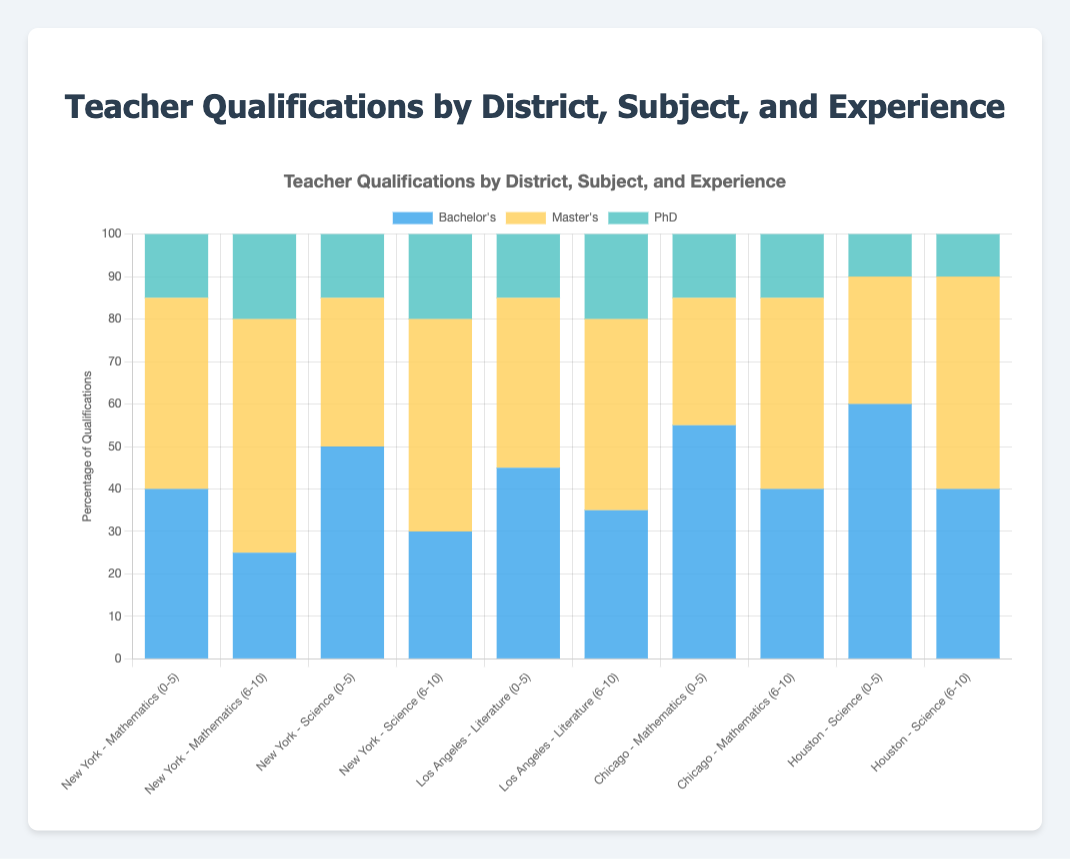What's the percentage of teachers with a Master's degree in Mathematics with 6-10 years of experience in New York? The chart shows that for Mathematics in New York with 6-10 years of teaching experience, the percentage of teachers with a Master's degree is 55%.
Answer: 55% Which district has the highest percentage of teachers with a Bachelor's degree in Science with 0-5 years of experience? Houston has the highest percentage of teachers with a Bachelor's degree in Science with 0-5 years of experience, which is 60%, as shown in the chart.
Answer: Houston Compare the percentage of teachers with a PhD in Literature with 6-10 years of experience in Los Angeles to those in New York for Science with 6-10 years of experience. Which is higher? The chart shows that in Los Angeles, the percentage of teachers with a PhD in Literature with 6-10 years of experience is 20%, while in New York for Science with 6-10 years, it is also 20%. Therefore, they are equal.
Answer: Equal What is the combined percentage of teachers with Bachelor's and Master's degrees for Mathematics with 0-5 years of experience in Chicago? In Chicago, for Mathematics with 0-5 years experience, the chart shows 55% with Bachelor's and 30% with Master's degrees. The combined percentage is 55 + 30 = 85%.
Answer: 85% Which subject has a higher percentage of teachers with a Master's degree in New York with 0-5 years of experience: Mathematics or Science? In New York, the chart shows 45% of Mathematics teachers with a Master's degree and 35% of Science teachers with a Master's degree with 0-5 years of experience. Mathematics has a higher percentage.
Answer: Mathematics What is the difference in the percentage of teachers with PhD degrees in Mathematics with 6-10 years of experience between New York and Chicago? In New York, the percentage for Mathematics with 6-10 years experience is 20%, and in Chicago, it is 15%. The difference is 20 - 15 = 5%.
Answer: 5% How does the percentage of teachers with Bachelor's degrees in Literature with 0-5 years of experience compare between Los Angeles and New York? In Los Angeles, the percentage is 45%, but there is no data for Literature in New York for 0-5 years of experience. Therefore, a direct comparison can't be made.
Answer: Cannot be compared What is the total percentage of qualifications (Bachelor's, Master's, and PhD) for Science in Houston with 0-5 years of experience? In Houston for Science with 0-5 years experience, the chart shows 60% Bachelor's, 30% Master's, and 10% PhD. The total percentage is 60 + 30 + 10 = 100%.
Answer: 100% Which teaching experience group in New York has a higher percentage of teachers with PhDs in Science, 0-5 years or 6-10 years? For Science in New York, the chart shows that both teaching experience groups (0-5 years and 6-10 years) have the same percentage of teachers with PhDs, which is 15%.
Answer: Equal What is the percentage of teachers with Master's degrees in Chicago for Mathematics with 6-10 years of experience? The chart shows that for Mathematics in Chicago with 6-10 years of teaching experience, the percentage of teachers with a Master's degree is 45%.
Answer: 45% 